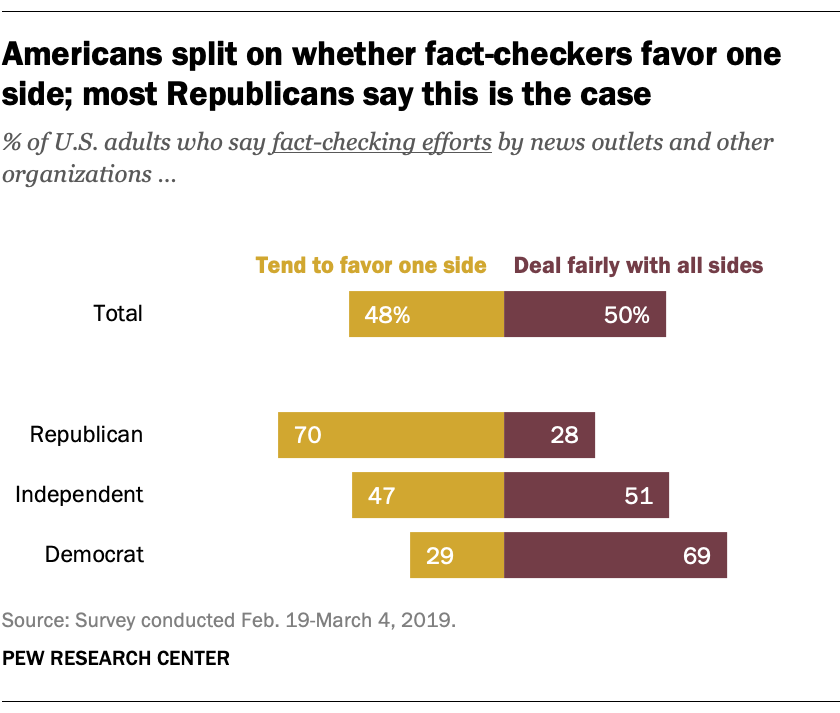Draw attention to some important aspects in this diagram. The color yellow in the graph has a total value of 48%. 